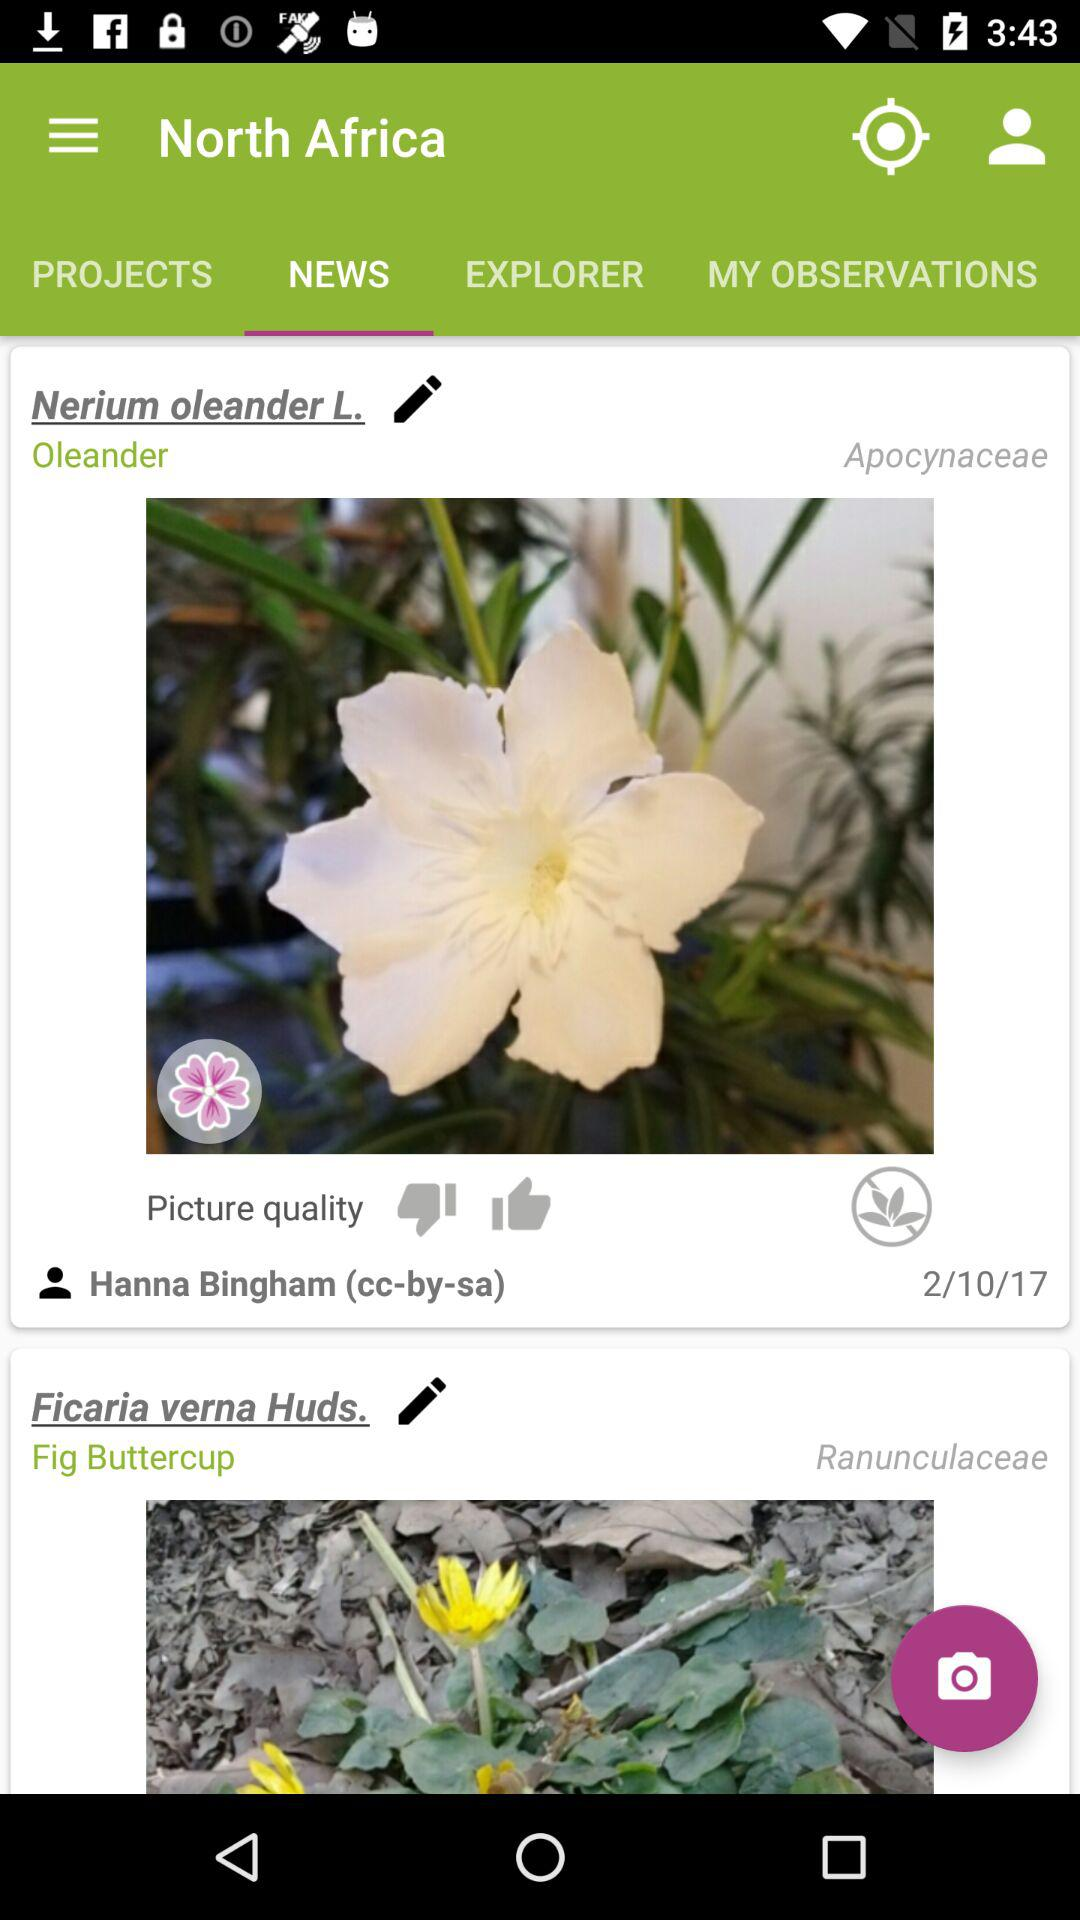What is the scientific name of oleander? The scientific name is "Nerium oleander". 